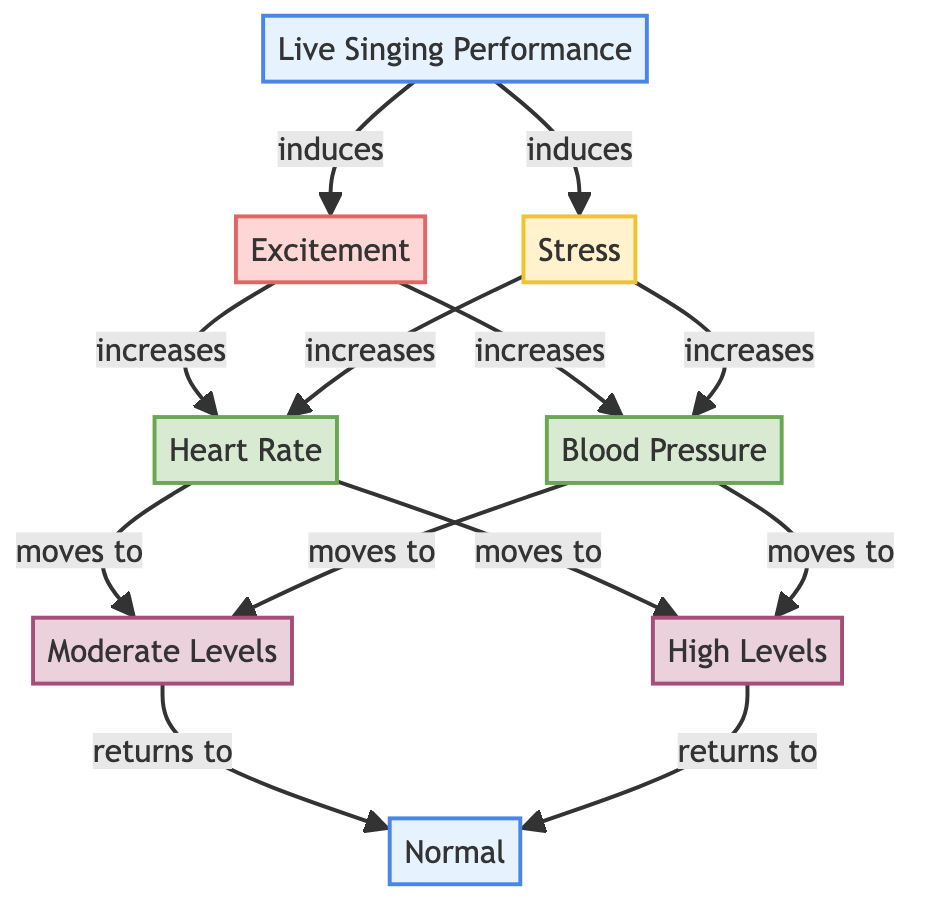What induces stress and excitement in the diagram? The diagram shows that a "Live Singing Performance" induces both "Excitement" and "Stress". Both paths originate from the node representing the performance.
Answer: Live Singing Performance What happens to Heart Rate during excitement and stress? The diagram indicates that both "Excitement" and "Stress" lead to an increase in "Heart Rate". Each flowchart line shows these connections with the arrows pointing towards "Heart Rate".
Answer: Increases How many levels of blood pressure are depicted in the diagram? The diagram includes three blood pressure levels: "Normal," "Moderate," and "High." Each of these levels is represented as a separate node.
Answer: Three What is the final status of Heart Rate after it moves through the levels? According to the diagram, after moving through "Moderate" and "High," Heart Rate returns to "Normal." The link from "Moderate" and "High" both point back to "Normal."
Answer: Normal What are the physiological parameters tracked in the diagram? The diagram tracks "Heart Rate" and "Blood Pressure" as the main physiological parameters, both labeled under the physiological class.
Answer: Heart Rate, Blood Pressure What color represents excitement in the diagram? In the diagram, excitement is represented by a light red shade (fill: #ffd6d6) and a darker red stroke (#e06666), indicating its emotional intensity.
Answer: Light red What occurs to blood pressure levels during a live performance? The diagram indicates that blood pressure levels increase due to "Excitement" and "Stress," moving to "Moderate" and "High" levels. This follows the arrows showing the cause-effect relationship.
Answer: Increases What is the relationship between excitement and blood pressure? "Excitement" increases "Blood Pressure," as shown by the arrow connecting "Excitement" to the "Blood Pressure" node in the diagram.
Answer: Increases 